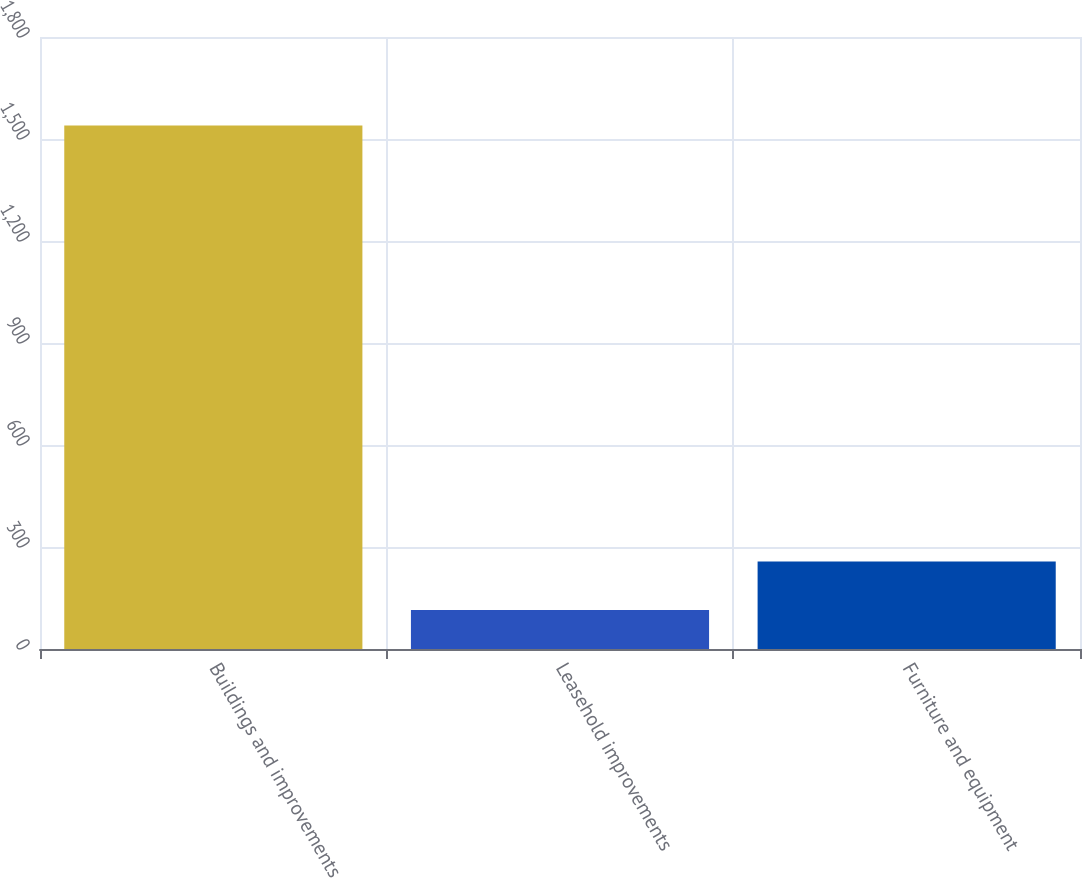<chart> <loc_0><loc_0><loc_500><loc_500><bar_chart><fcel>Buildings and improvements<fcel>Leasehold improvements<fcel>Furniture and equipment<nl><fcel>1540<fcel>115<fcel>257.5<nl></chart> 